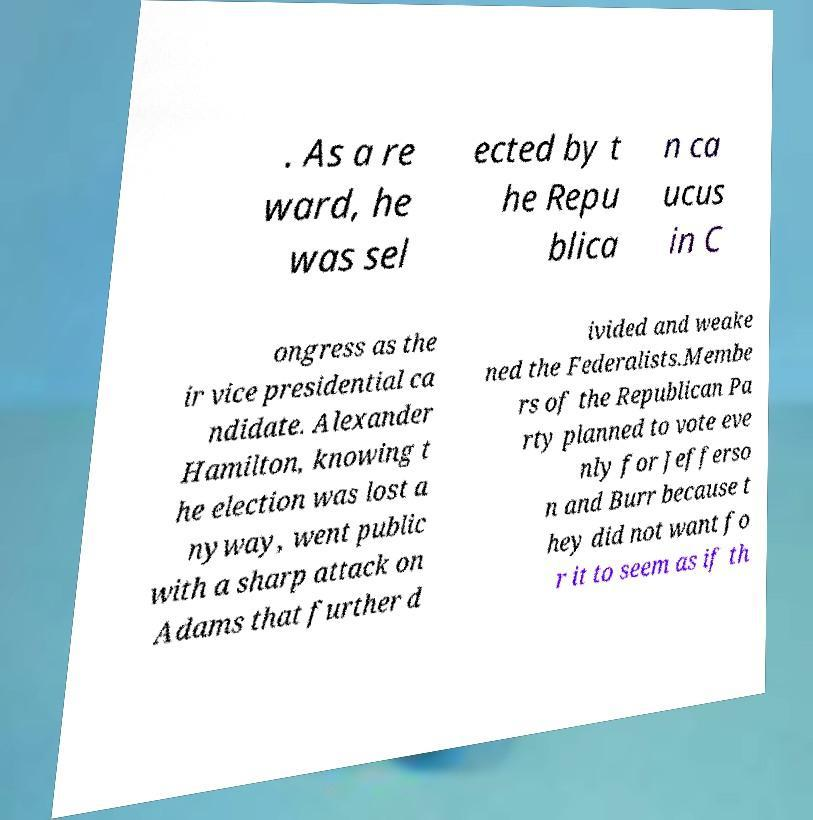Please identify and transcribe the text found in this image. . As a re ward, he was sel ected by t he Repu blica n ca ucus in C ongress as the ir vice presidential ca ndidate. Alexander Hamilton, knowing t he election was lost a nyway, went public with a sharp attack on Adams that further d ivided and weake ned the Federalists.Membe rs of the Republican Pa rty planned to vote eve nly for Jefferso n and Burr because t hey did not want fo r it to seem as if th 